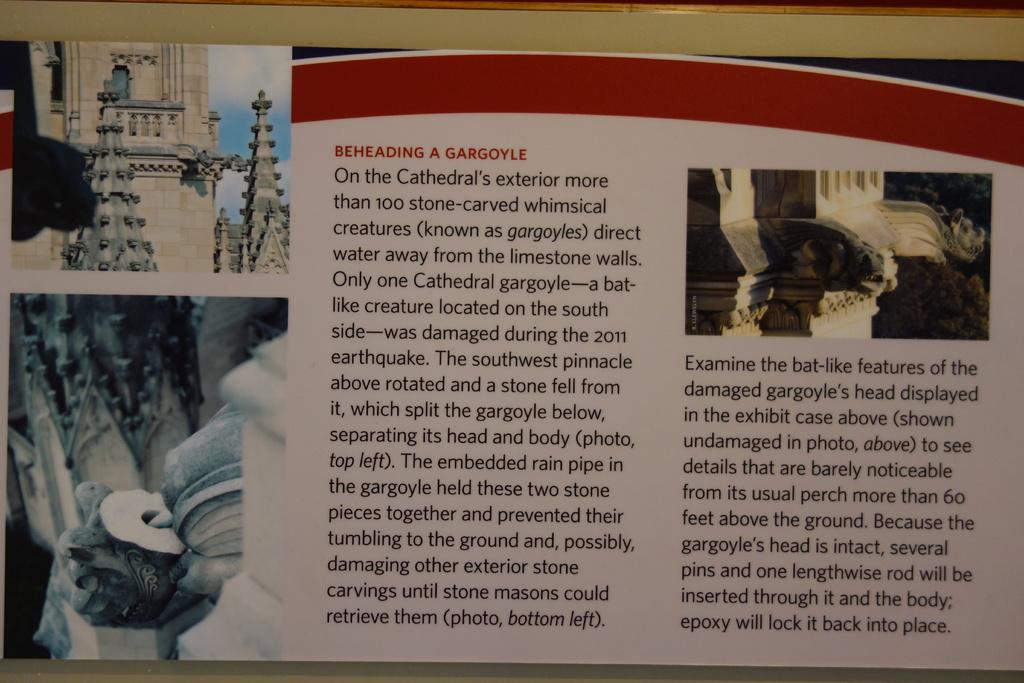What is being beheaded?
Offer a very short reply. Gargoyle. What is the last word on this sign?
Your response must be concise. Place. 